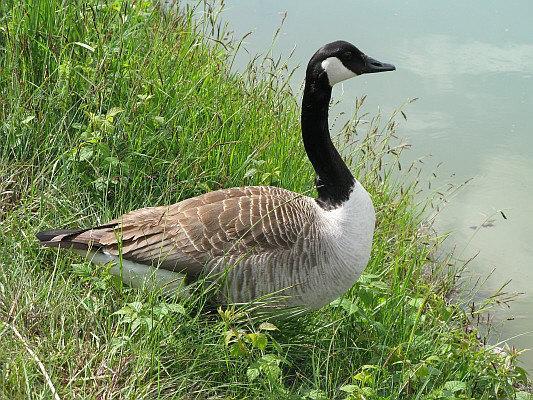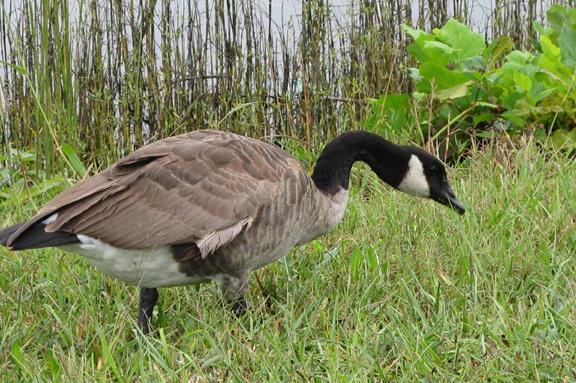The first image is the image on the left, the second image is the image on the right. Examine the images to the left and right. Is the description "Only geese with black and white faces are shown." accurate? Answer yes or no. Yes. 